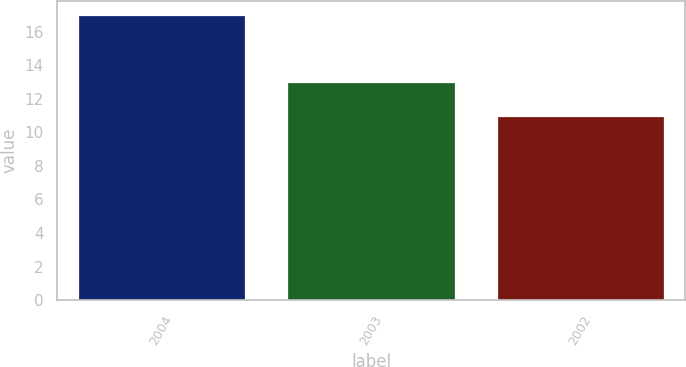Convert chart. <chart><loc_0><loc_0><loc_500><loc_500><bar_chart><fcel>2004<fcel>2003<fcel>2002<nl><fcel>17<fcel>13<fcel>11<nl></chart> 